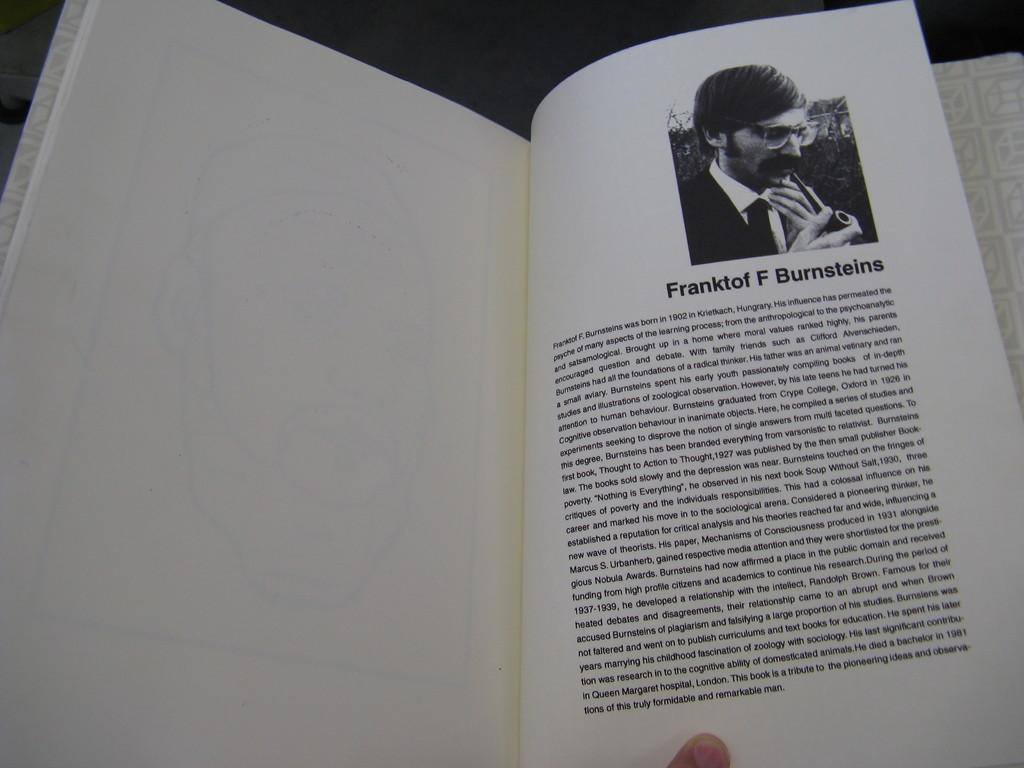<image>
Render a clear and concise summary of the photo. Person reading a book with the name "Franktof F Burnsteins" on the top. 